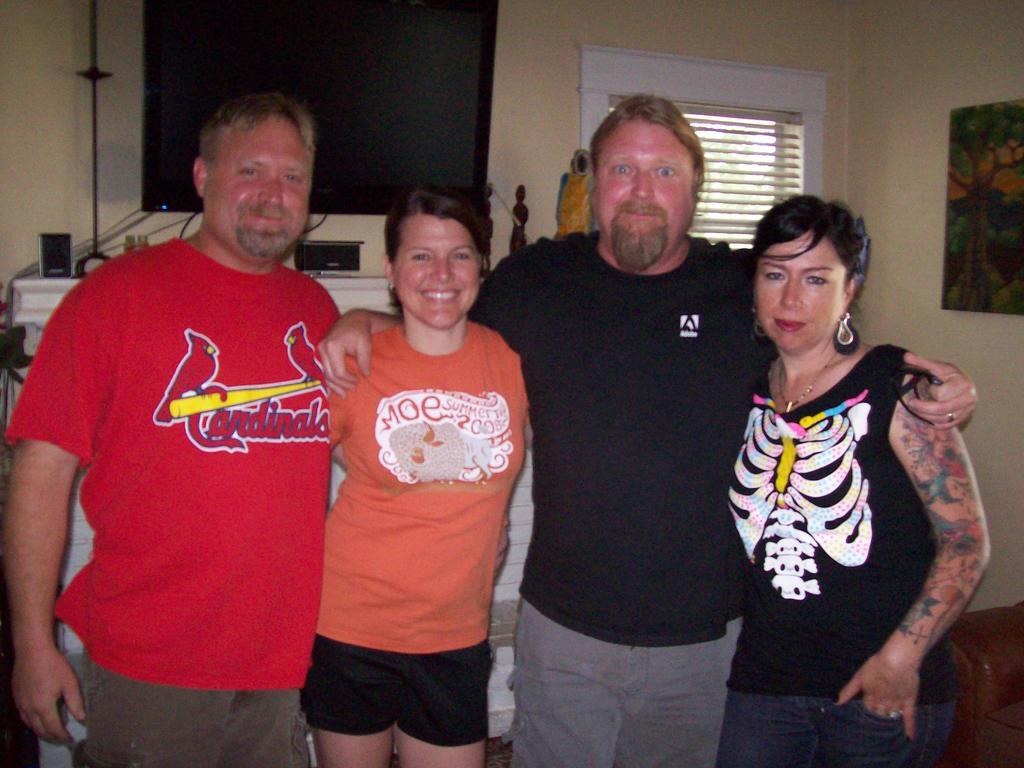What team does the red shirt represent?
Your response must be concise. Cardinals. What does it say on the top left of the orange shirt?
Provide a short and direct response. Moe. 